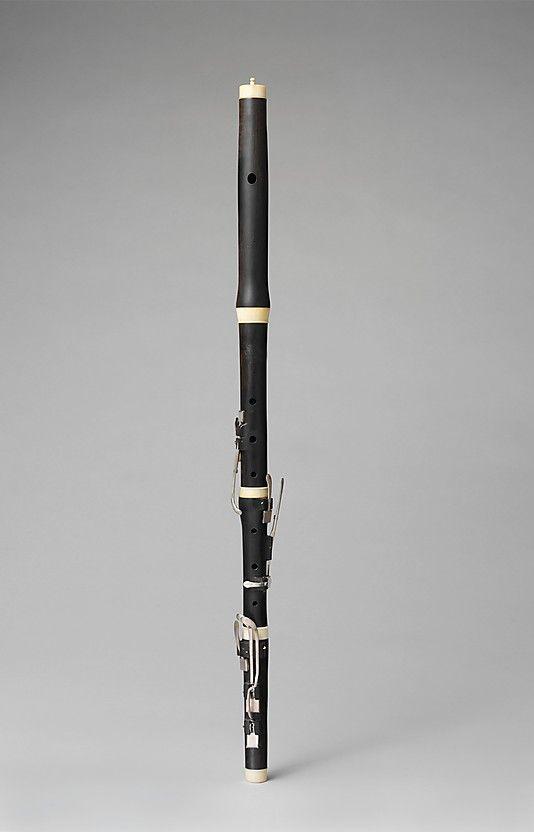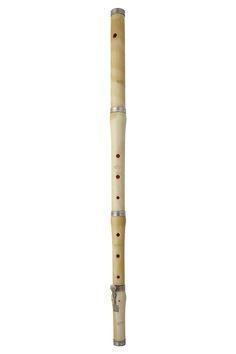The first image is the image on the left, the second image is the image on the right. Considering the images on both sides, is "The background of one of the images is blue." valid? Answer yes or no. No. The first image is the image on the left, the second image is the image on the right. For the images displayed, is the sentence "One image contains exactly four wooden flutes displayed in a row, with cords at their tops." factually correct? Answer yes or no. No. 